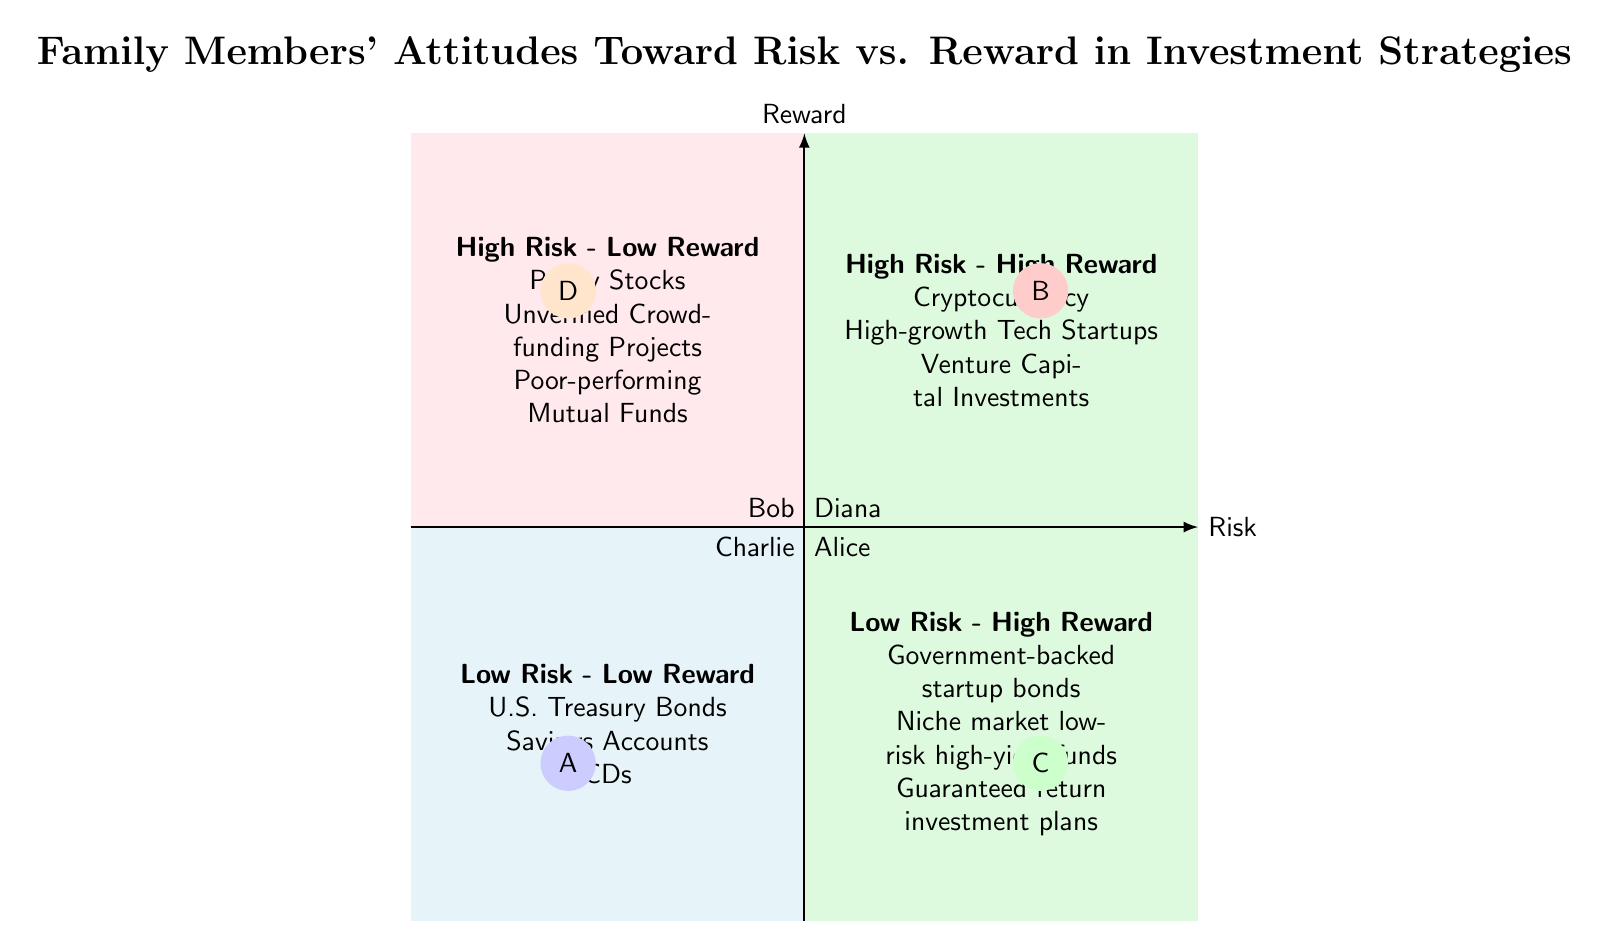What quadrant is Alice in? Alice has a "Low Risk" and "Low Reward" preference, which places her in the "Low Risk - Low Reward" quadrant according to the classification provided in the diagram.
Answer: Low Risk - Low Reward How many family members prefer "High Risk - High Reward" strategies? Bob is the only family member with a "High Risk" and "High Reward" preference, which defines the "High Risk - High Reward" quadrant. Thus, there is only one member in this category.
Answer: 1 Which investment type is associated with the "High Risk - Low Reward" quadrant? The "High Risk - Low Reward" quadrant includes investment options like Penny Stocks, Unverified Crowdfunding Projects, and Poor-performing Mutual Funds as stated in the diagram.
Answer: Penny Stocks What is the reward preference of Charlie? Charlie exhibits a "High Reward" preference as indicated by his placement in the "Low Risk - High Reward" quadrant on the diagram.
Answer: High Reward Which family member prefers the lowest risk and lowest reward? The question specifies a preference for the lowest risk combined with the lowest reward, which clearly identifies Alice as positioned in the "Low Risk - Low Reward" quadrant.
Answer: Alice What type of investments do family members higher on the reward scale generally prefer? The diagram indicates that family members who are higher on the reward scale, particularly in the "High Reward" quadrants, tend to favor investments such as Cryptocurrency, High-growth Tech Startups, and Venture Capital Investments.
Answer: Cryptocurrency What quadrant does Diana belong to? Diana demonstrates a "High Risk" and "Low Reward" preference, which places her in the "High Risk - Low Reward" quadrant in the diagram.
Answer: High Risk - Low Reward Which quadrant has examples like guaranteed return investment plans? The "Low Risk - High Reward" quadrant includes examples like guaranteed return investment plans, as specified in the diagram.
Answer: Low Risk - High Reward In which quadrant would you find government-backed startup bonds? Government-backed startup bonds are categorized under the "Low Risk - High Reward" quadrant based on the explanation of the quadrants provided in the diagram.
Answer: Low Risk - High Reward 